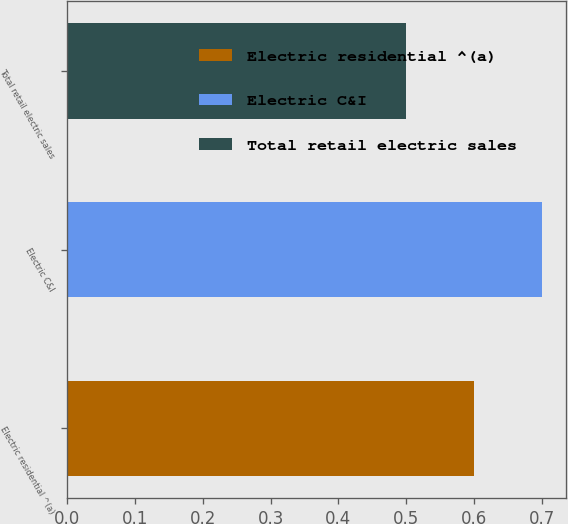<chart> <loc_0><loc_0><loc_500><loc_500><bar_chart><fcel>Electric residential ^(a)<fcel>Electric C&I<fcel>Total retail electric sales<nl><fcel>0.6<fcel>0.7<fcel>0.5<nl></chart> 